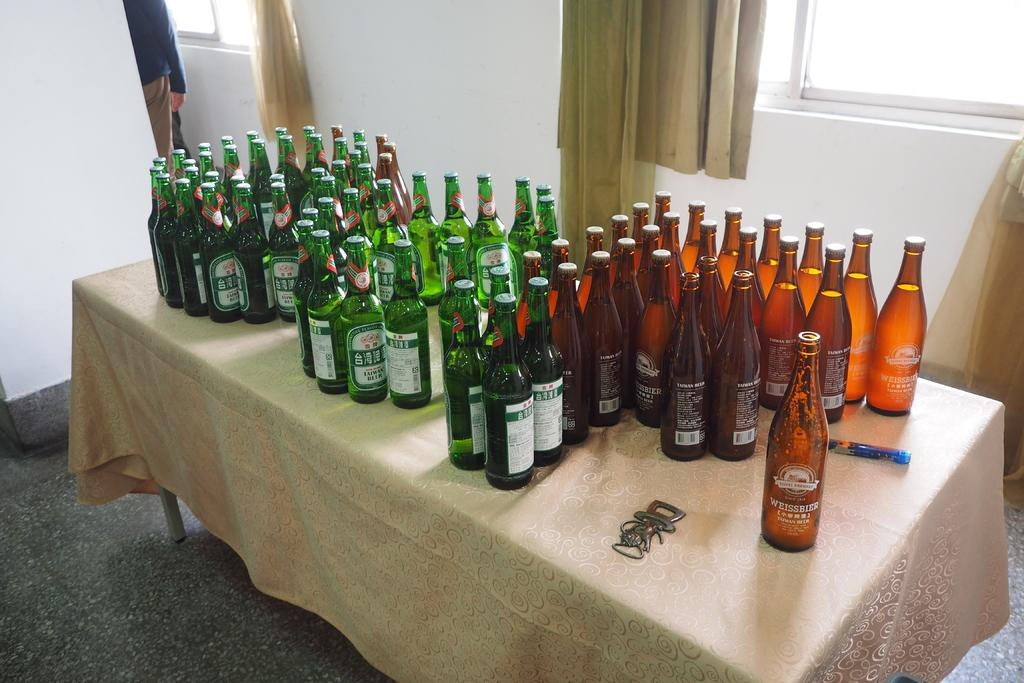What is the main subject of the image? The main subject of the image is many beer bottles on a table. Can you describe the table setting in the image? There is a window with curtains on the right side of the table in the image. What scientific experiment is being conducted with the beer bottles in the image? There is no scientific experiment being conducted with the beer bottles in the image; they are simply sitting on a table. 